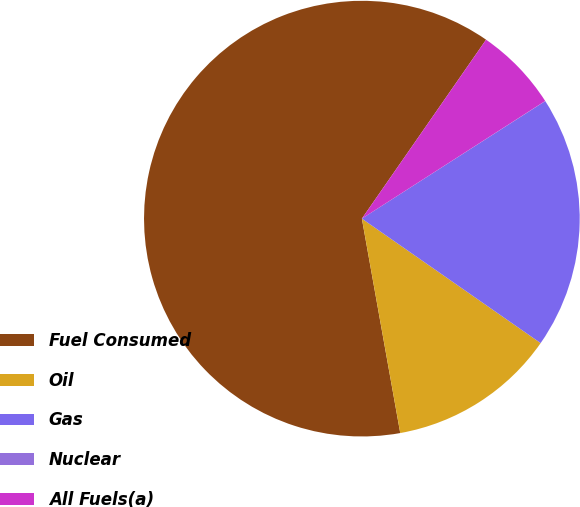Convert chart to OTSL. <chart><loc_0><loc_0><loc_500><loc_500><pie_chart><fcel>Fuel Consumed<fcel>Oil<fcel>Gas<fcel>Nuclear<fcel>All Fuels(a)<nl><fcel>62.47%<fcel>12.5%<fcel>18.75%<fcel>0.01%<fcel>6.26%<nl></chart> 